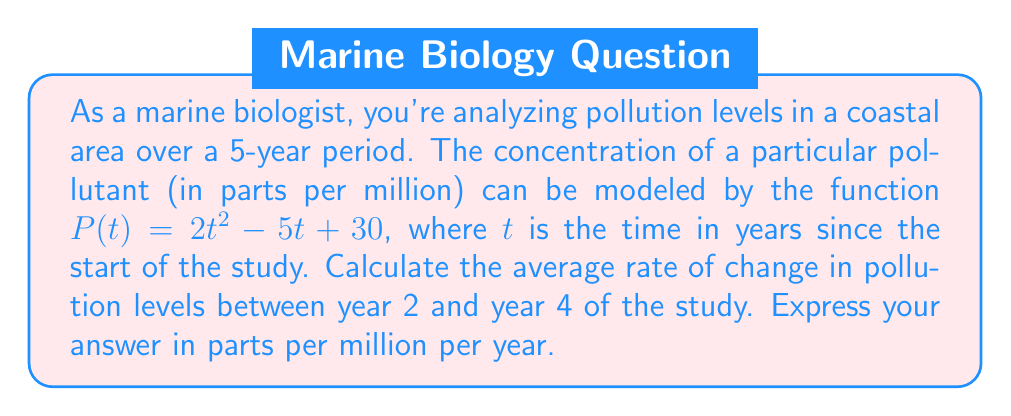What is the answer to this math problem? To find the average rate of change between two points, we use the formula:

$$\text{Average rate of change} = \frac{f(b) - f(a)}{b - a}$$

Where $a$ and $b$ are the initial and final time points, respectively.

1) First, let's calculate the pollution levels at $t = 2$ and $t = 4$:

   For $t = 2$: 
   $P(2) = 2(2)^2 - 5(2) + 30 = 2(4) - 10 + 30 = 8 - 10 + 30 = 28$ ppm

   For $t = 4$: 
   $P(4) = 2(4)^2 - 5(4) + 30 = 2(16) - 20 + 30 = 32 - 20 + 30 = 42$ ppm

2) Now, let's apply the average rate of change formula:

   $$\text{Average rate of change} = \frac{P(4) - P(2)}{4 - 2} = \frac{42 - 28}{2} = \frac{14}{2} = 7$$

Therefore, the average rate of change in pollution levels between year 2 and year 4 is 7 parts per million per year.
Answer: 7 parts per million per year 